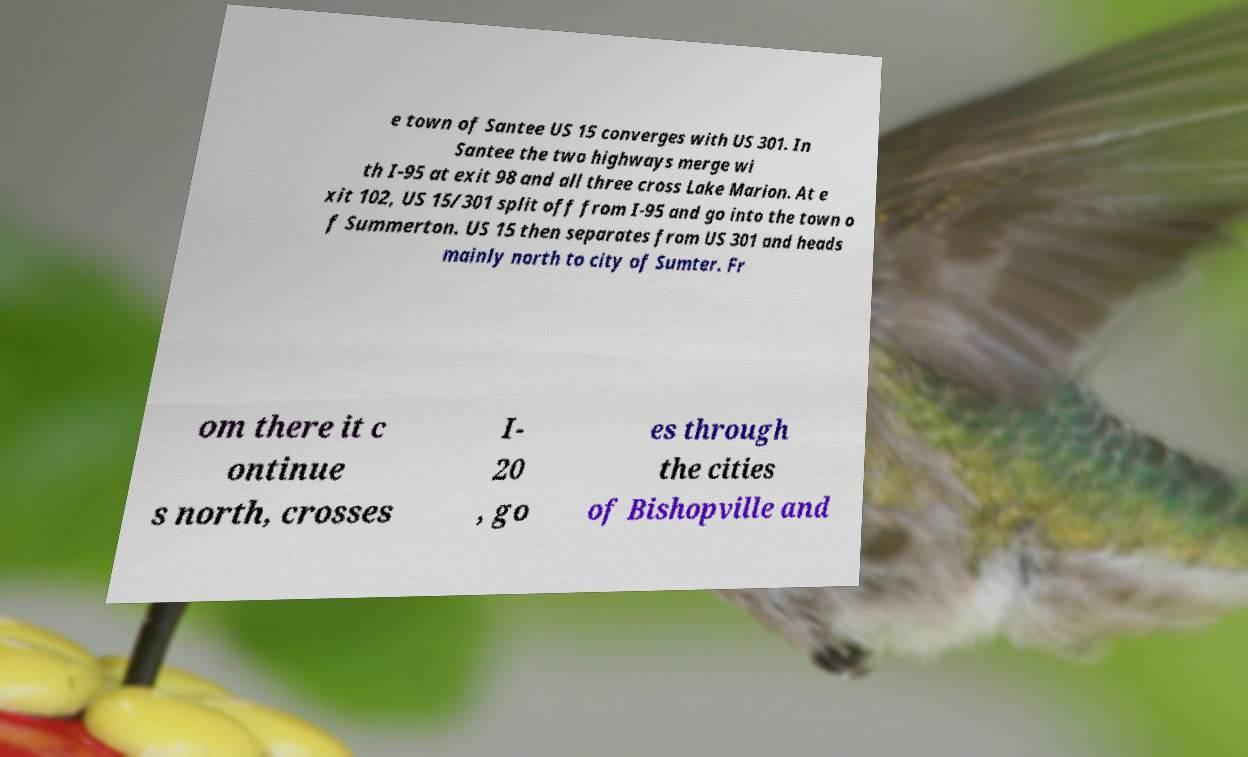Can you read and provide the text displayed in the image?This photo seems to have some interesting text. Can you extract and type it out for me? e town of Santee US 15 converges with US 301. In Santee the two highways merge wi th I-95 at exit 98 and all three cross Lake Marion. At e xit 102, US 15/301 split off from I-95 and go into the town o f Summerton. US 15 then separates from US 301 and heads mainly north to city of Sumter. Fr om there it c ontinue s north, crosses I- 20 , go es through the cities of Bishopville and 